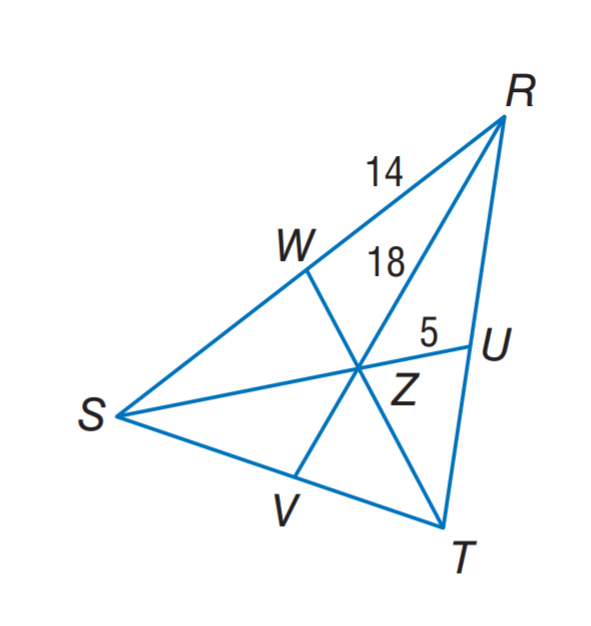Answer the mathemtical geometry problem and directly provide the correct option letter.
Question: In \triangle R S T, Z is the centroid and R Z = 18. Find Z V.
Choices: A: 5 B: 9 C: 10 D: 18 B 